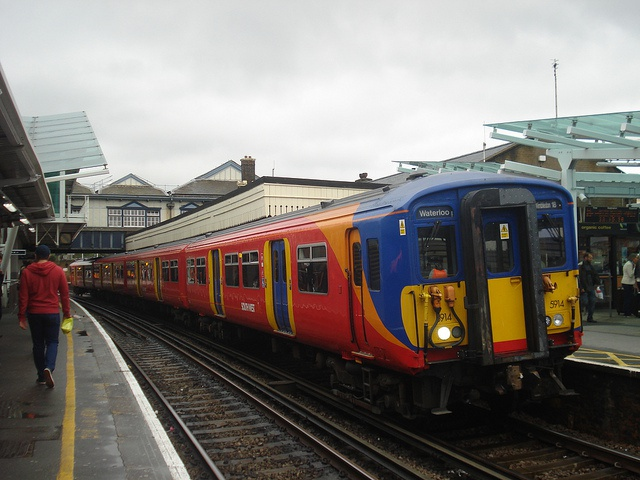Describe the objects in this image and their specific colors. I can see train in lightgray, black, maroon, navy, and olive tones, people in lightgray, black, maroon, brown, and gray tones, people in lightgray, black, maroon, and gray tones, and people in lightgray, black, gray, and darkgray tones in this image. 